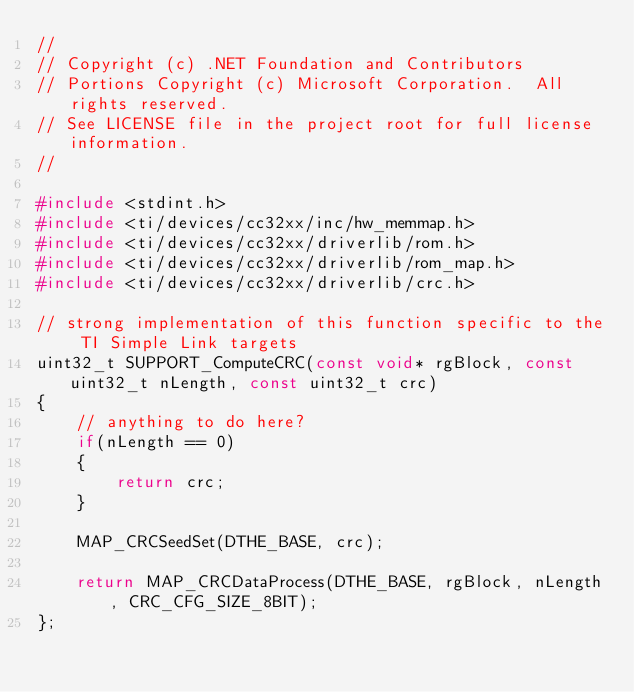<code> <loc_0><loc_0><loc_500><loc_500><_C_>//
// Copyright (c) .NET Foundation and Contributors
// Portions Copyright (c) Microsoft Corporation.  All rights reserved.
// See LICENSE file in the project root for full license information.
//

#include <stdint.h>
#include <ti/devices/cc32xx/inc/hw_memmap.h>
#include <ti/devices/cc32xx/driverlib/rom.h>
#include <ti/devices/cc32xx/driverlib/rom_map.h>
#include <ti/devices/cc32xx/driverlib/crc.h>

// strong implementation of this function specific to the TI Simple Link targets
uint32_t SUPPORT_ComputeCRC(const void* rgBlock, const uint32_t nLength, const uint32_t crc)
{
	// anything to do here?
    if(nLength == 0)
    {
        return crc;
    }

	MAP_CRCSeedSet(DTHE_BASE, crc);

	return MAP_CRCDataProcess(DTHE_BASE, rgBlock, nLength, CRC_CFG_SIZE_8BIT);
};
</code> 